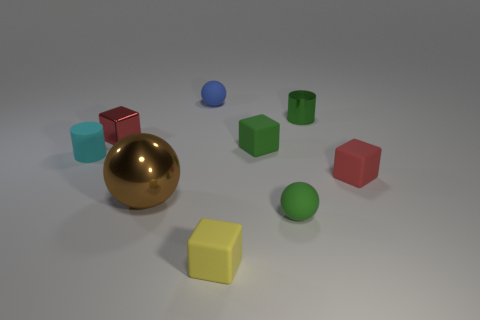Subtract 1 blocks. How many blocks are left? 3 Add 1 red rubber cubes. How many objects exist? 10 Subtract all cylinders. How many objects are left? 7 Add 1 big cyan rubber objects. How many big cyan rubber objects exist? 1 Subtract 0 gray cylinders. How many objects are left? 9 Subtract all green rubber blocks. Subtract all tiny green rubber blocks. How many objects are left? 7 Add 6 metallic objects. How many metallic objects are left? 9 